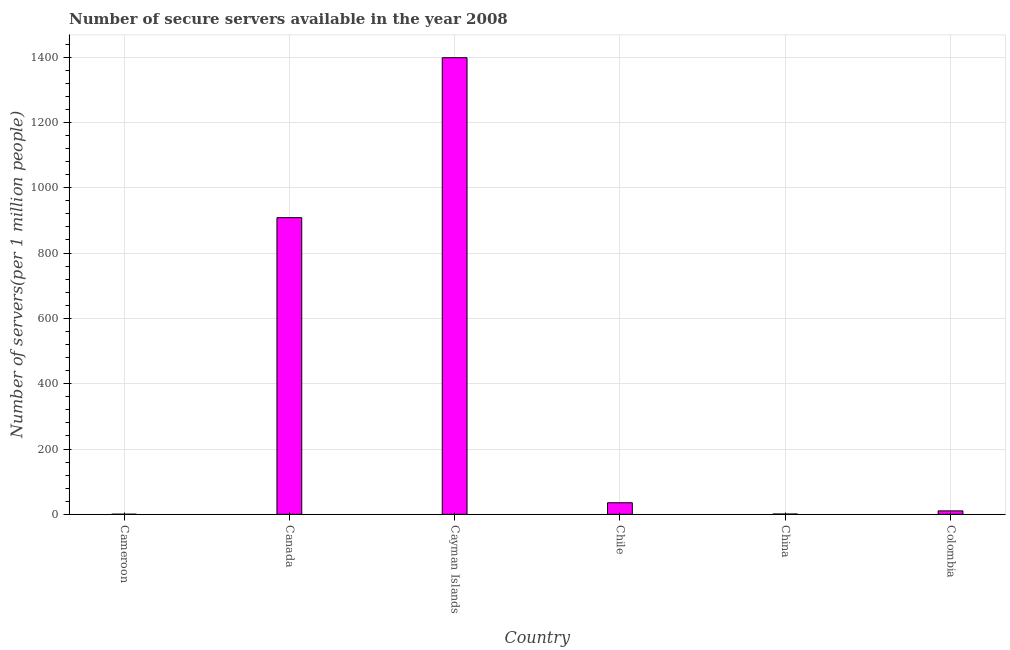What is the title of the graph?
Keep it short and to the point. Number of secure servers available in the year 2008. What is the label or title of the X-axis?
Provide a short and direct response. Country. What is the label or title of the Y-axis?
Offer a very short reply. Number of servers(per 1 million people). What is the number of secure internet servers in Canada?
Offer a terse response. 908.39. Across all countries, what is the maximum number of secure internet servers?
Offer a very short reply. 1398.21. Across all countries, what is the minimum number of secure internet servers?
Make the answer very short. 0.36. In which country was the number of secure internet servers maximum?
Offer a very short reply. Cayman Islands. In which country was the number of secure internet servers minimum?
Ensure brevity in your answer.  Cameroon. What is the sum of the number of secure internet servers?
Your answer should be compact. 2353.78. What is the difference between the number of secure internet servers in Chile and China?
Offer a very short reply. 34.45. What is the average number of secure internet servers per country?
Offer a terse response. 392.3. What is the median number of secure internet servers?
Your response must be concise. 22.95. In how many countries, is the number of secure internet servers greater than 720 ?
Offer a terse response. 2. What is the ratio of the number of secure internet servers in Cayman Islands to that in Chile?
Make the answer very short. 39.52. What is the difference between the highest and the second highest number of secure internet servers?
Provide a short and direct response. 489.82. What is the difference between the highest and the lowest number of secure internet servers?
Offer a very short reply. 1397.85. Are all the bars in the graph horizontal?
Offer a very short reply. No. What is the Number of servers(per 1 million people) of Cameroon?
Offer a terse response. 0.36. What is the Number of servers(per 1 million people) in Canada?
Provide a succinct answer. 908.39. What is the Number of servers(per 1 million people) in Cayman Islands?
Keep it short and to the point. 1398.21. What is the Number of servers(per 1 million people) in Chile?
Give a very brief answer. 35.38. What is the Number of servers(per 1 million people) of China?
Provide a short and direct response. 0.93. What is the Number of servers(per 1 million people) in Colombia?
Your answer should be very brief. 10.51. What is the difference between the Number of servers(per 1 million people) in Cameroon and Canada?
Your answer should be compact. -908.03. What is the difference between the Number of servers(per 1 million people) in Cameroon and Cayman Islands?
Provide a succinct answer. -1397.85. What is the difference between the Number of servers(per 1 million people) in Cameroon and Chile?
Keep it short and to the point. -35.03. What is the difference between the Number of servers(per 1 million people) in Cameroon and China?
Keep it short and to the point. -0.58. What is the difference between the Number of servers(per 1 million people) in Cameroon and Colombia?
Provide a short and direct response. -10.15. What is the difference between the Number of servers(per 1 million people) in Canada and Cayman Islands?
Provide a succinct answer. -489.82. What is the difference between the Number of servers(per 1 million people) in Canada and Chile?
Give a very brief answer. 873. What is the difference between the Number of servers(per 1 million people) in Canada and China?
Provide a succinct answer. 907.45. What is the difference between the Number of servers(per 1 million people) in Canada and Colombia?
Give a very brief answer. 897.87. What is the difference between the Number of servers(per 1 million people) in Cayman Islands and Chile?
Provide a succinct answer. 1362.82. What is the difference between the Number of servers(per 1 million people) in Cayman Islands and China?
Give a very brief answer. 1397.27. What is the difference between the Number of servers(per 1 million people) in Cayman Islands and Colombia?
Your answer should be very brief. 1387.69. What is the difference between the Number of servers(per 1 million people) in Chile and China?
Keep it short and to the point. 34.45. What is the difference between the Number of servers(per 1 million people) in Chile and Colombia?
Offer a very short reply. 24.87. What is the difference between the Number of servers(per 1 million people) in China and Colombia?
Your answer should be compact. -9.58. What is the ratio of the Number of servers(per 1 million people) in Cameroon to that in Canada?
Your answer should be compact. 0. What is the ratio of the Number of servers(per 1 million people) in Cameroon to that in Cayman Islands?
Keep it short and to the point. 0. What is the ratio of the Number of servers(per 1 million people) in Cameroon to that in Chile?
Your answer should be very brief. 0.01. What is the ratio of the Number of servers(per 1 million people) in Cameroon to that in China?
Ensure brevity in your answer.  0.38. What is the ratio of the Number of servers(per 1 million people) in Cameroon to that in Colombia?
Ensure brevity in your answer.  0.03. What is the ratio of the Number of servers(per 1 million people) in Canada to that in Cayman Islands?
Offer a terse response. 0.65. What is the ratio of the Number of servers(per 1 million people) in Canada to that in Chile?
Your answer should be very brief. 25.67. What is the ratio of the Number of servers(per 1 million people) in Canada to that in China?
Give a very brief answer. 971.97. What is the ratio of the Number of servers(per 1 million people) in Canada to that in Colombia?
Your answer should be compact. 86.42. What is the ratio of the Number of servers(per 1 million people) in Cayman Islands to that in Chile?
Make the answer very short. 39.52. What is the ratio of the Number of servers(per 1 million people) in Cayman Islands to that in China?
Keep it short and to the point. 1496.07. What is the ratio of the Number of servers(per 1 million people) in Cayman Islands to that in Colombia?
Give a very brief answer. 133.01. What is the ratio of the Number of servers(per 1 million people) in Chile to that in China?
Your response must be concise. 37.86. What is the ratio of the Number of servers(per 1 million people) in Chile to that in Colombia?
Keep it short and to the point. 3.37. What is the ratio of the Number of servers(per 1 million people) in China to that in Colombia?
Your answer should be very brief. 0.09. 